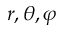<formula> <loc_0><loc_0><loc_500><loc_500>r , \theta , \varphi</formula> 